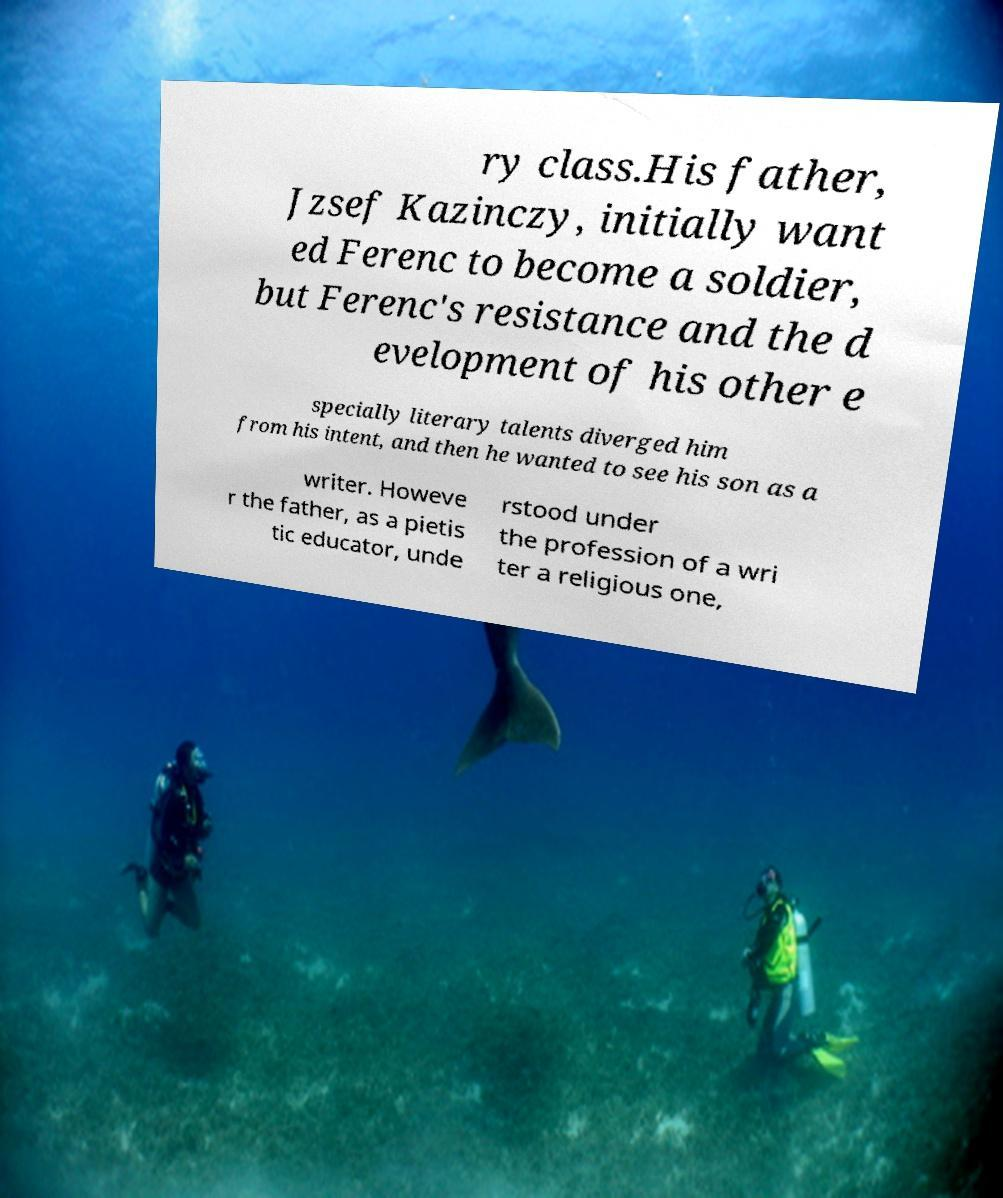Please identify and transcribe the text found in this image. ry class.His father, Jzsef Kazinczy, initially want ed Ferenc to become a soldier, but Ferenc's resistance and the d evelopment of his other e specially literary talents diverged him from his intent, and then he wanted to see his son as a writer. Howeve r the father, as a pietis tic educator, unde rstood under the profession of a wri ter a religious one, 